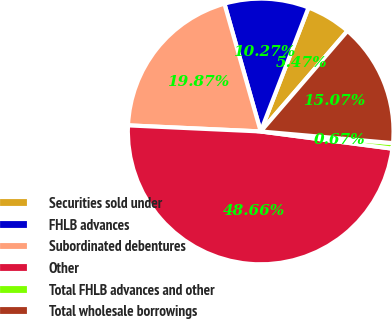Convert chart. <chart><loc_0><loc_0><loc_500><loc_500><pie_chart><fcel>Securities sold under<fcel>FHLB advances<fcel>Subordinated debentures<fcel>Other<fcel>Total FHLB advances and other<fcel>Total wholesale borrowings<nl><fcel>5.47%<fcel>10.27%<fcel>19.87%<fcel>48.67%<fcel>0.67%<fcel>15.07%<nl></chart> 